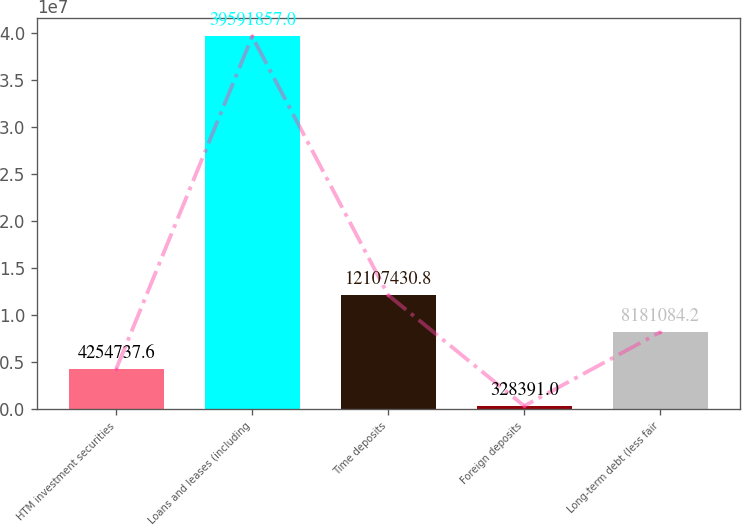<chart> <loc_0><loc_0><loc_500><loc_500><bar_chart><fcel>HTM investment securities<fcel>Loans and leases (including<fcel>Time deposits<fcel>Foreign deposits<fcel>Long-term debt (less fair<nl><fcel>4.25474e+06<fcel>3.95919e+07<fcel>1.21074e+07<fcel>328391<fcel>8.18108e+06<nl></chart> 